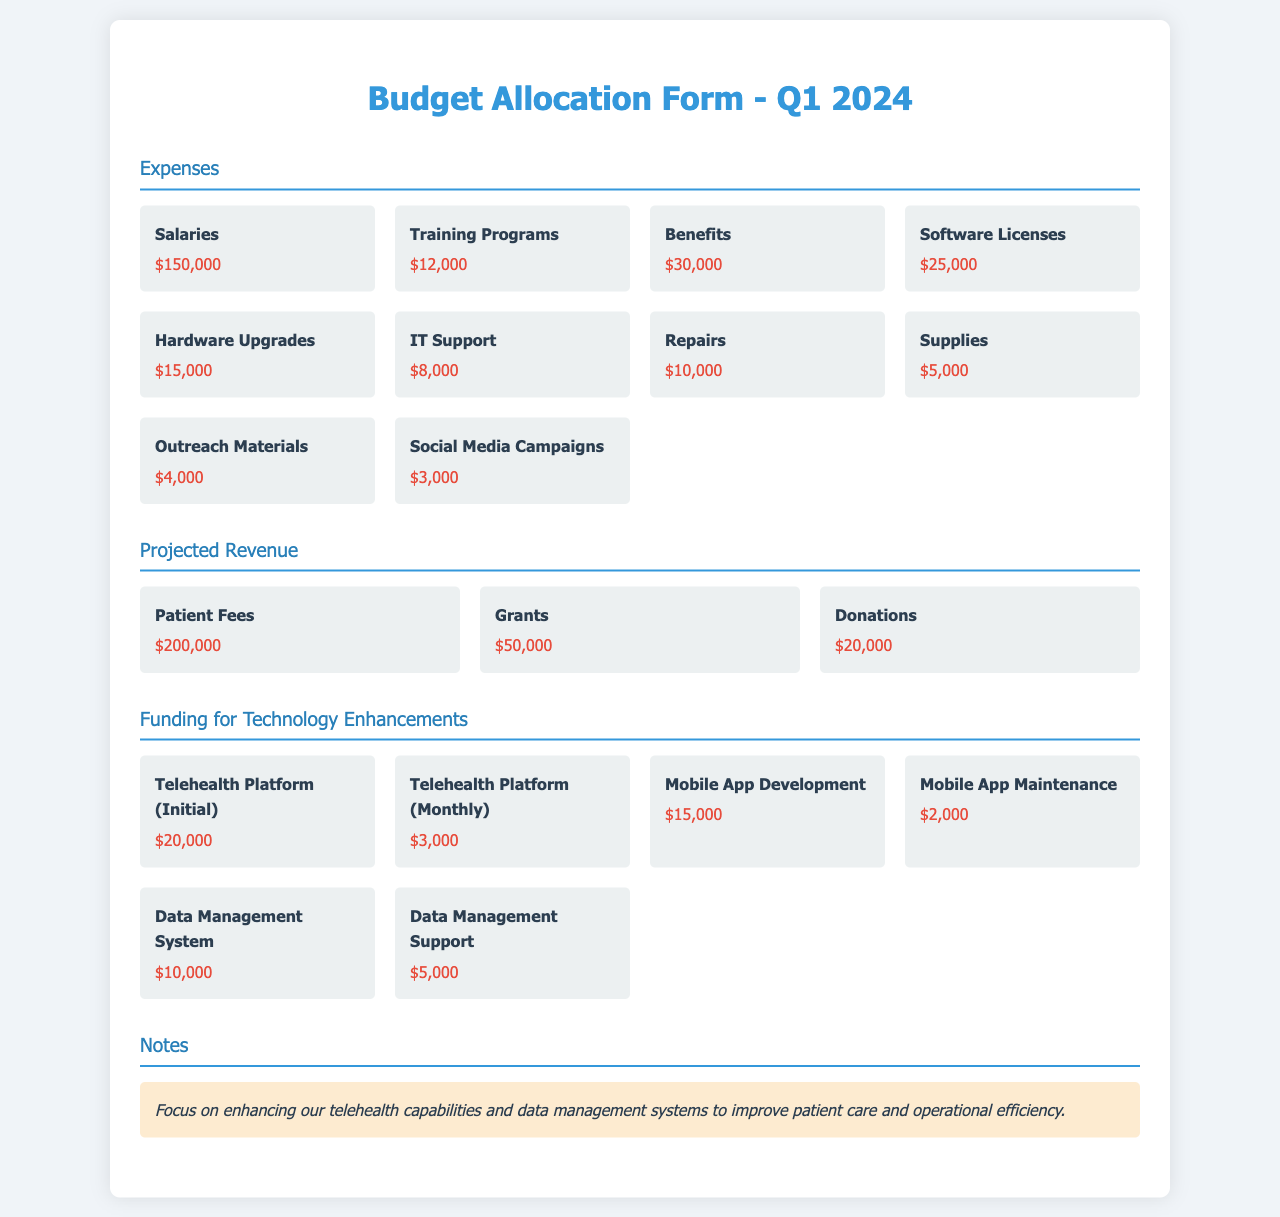what is the total expense for salaries? The total expense for salaries is specifically stated in the Expenses section of the document as $150,000.
Answer: $150,000 what is the projected revenue from grants? The projected revenue from grants is listed in the Projected Revenue section of the document as $50,000.
Answer: $50,000 how much is allocated for the telehealth platform (initial)? The amount allocated for the telehealth platform (initial) can be found in the Funding for Technology Enhancements section, which states $20,000.
Answer: $20,000 what is the total projected revenue? The total projected revenue is the sum of all revenue sources: Patient Fees $200,000 + Grants $50,000 + Donations $20,000 = $270,000.
Answer: $270,000 what is the total expense for supplies? The total expense for supplies is detailed in the Expenses section of the document as $5,000.
Answer: $5,000 what is the combined cost of the Mobile App Development and Maintenance? The combined cost is calculated by adding Mobile App Development $15,000 and Mobile App Maintenance $2,000, totaling $17,000.
Answer: $17,000 what is the total allocated for IT Support? The total allocated for IT Support is clearly marked in the Expenses section as $8,000.
Answer: $8,000 how many dollars are allocated for training programs? The amount allocated for training programs is stated in the Expenses section of the document as $12,000.
Answer: $12,000 what is the focus highlighted in the notes? The focus highlighted emphasizes enhancing telehealth capabilities and data management systems.
Answer: Telehealth capabilities and data management systems 